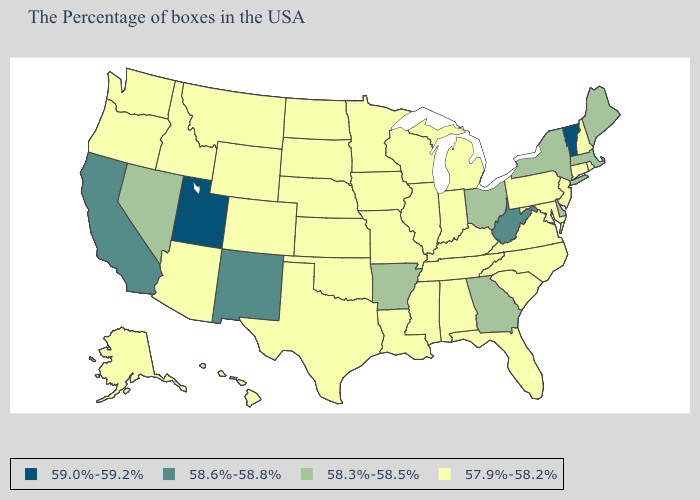Name the states that have a value in the range 58.6%-58.8%?
Be succinct. West Virginia, New Mexico, California. What is the highest value in the USA?
Give a very brief answer. 59.0%-59.2%. Among the states that border Nebraska , which have the lowest value?
Short answer required. Missouri, Iowa, Kansas, South Dakota, Wyoming, Colorado. What is the value of New Hampshire?
Write a very short answer. 57.9%-58.2%. What is the highest value in the West ?
Give a very brief answer. 59.0%-59.2%. What is the value of Washington?
Be succinct. 57.9%-58.2%. What is the value of Virginia?
Answer briefly. 57.9%-58.2%. Among the states that border North Carolina , which have the highest value?
Keep it brief. Georgia. What is the value of Tennessee?
Quick response, please. 57.9%-58.2%. Name the states that have a value in the range 59.0%-59.2%?
Concise answer only. Vermont, Utah. Name the states that have a value in the range 58.3%-58.5%?
Give a very brief answer. Maine, Massachusetts, New York, Delaware, Ohio, Georgia, Arkansas, Nevada. What is the lowest value in states that border Indiana?
Quick response, please. 57.9%-58.2%. Name the states that have a value in the range 58.6%-58.8%?
Answer briefly. West Virginia, New Mexico, California. What is the highest value in the Northeast ?
Answer briefly. 59.0%-59.2%. Among the states that border North Carolina , does South Carolina have the lowest value?
Give a very brief answer. Yes. 